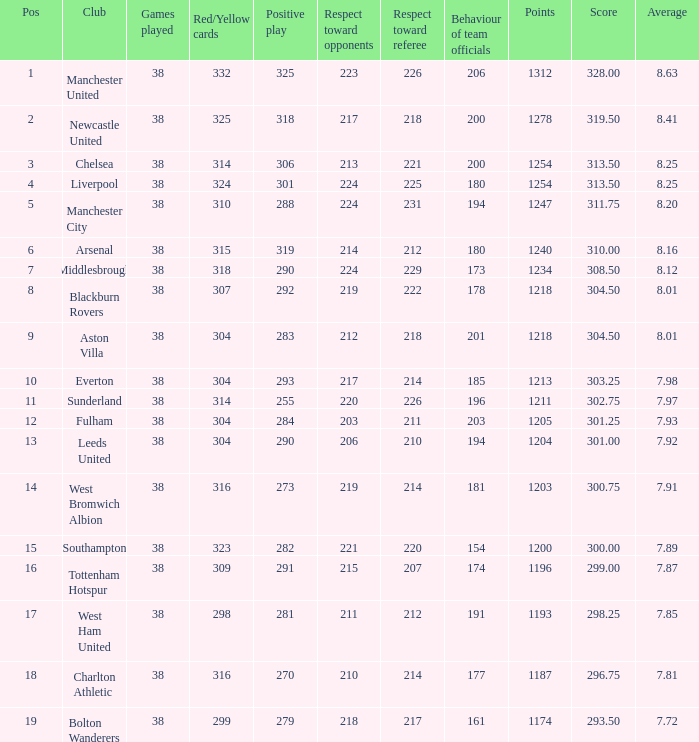Parse the table in full. {'header': ['Pos', 'Club', 'Games played', 'Red/Yellow cards', 'Positive play', 'Respect toward opponents', 'Respect toward referee', 'Behaviour of team officials', 'Points', 'Score', 'Average'], 'rows': [['1', 'Manchester United', '38', '332', '325', '223', '226', '206', '1312', '328.00', '8.63'], ['2', 'Newcastle United', '38', '325', '318', '217', '218', '200', '1278', '319.50', '8.41'], ['3', 'Chelsea', '38', '314', '306', '213', '221', '200', '1254', '313.50', '8.25'], ['4', 'Liverpool', '38', '324', '301', '224', '225', '180', '1254', '313.50', '8.25'], ['5', 'Manchester City', '38', '310', '288', '224', '231', '194', '1247', '311.75', '8.20'], ['6', 'Arsenal', '38', '315', '319', '214', '212', '180', '1240', '310.00', '8.16'], ['7', 'Middlesbrough', '38', '318', '290', '224', '229', '173', '1234', '308.50', '8.12'], ['8', 'Blackburn Rovers', '38', '307', '292', '219', '222', '178', '1218', '304.50', '8.01'], ['9', 'Aston Villa', '38', '304', '283', '212', '218', '201', '1218', '304.50', '8.01'], ['10', 'Everton', '38', '304', '293', '217', '214', '185', '1213', '303.25', '7.98'], ['11', 'Sunderland', '38', '314', '255', '220', '226', '196', '1211', '302.75', '7.97'], ['12', 'Fulham', '38', '304', '284', '203', '211', '203', '1205', '301.25', '7.93'], ['13', 'Leeds United', '38', '304', '290', '206', '210', '194', '1204', '301.00', '7.92'], ['14', 'West Bromwich Albion', '38', '316', '273', '219', '214', '181', '1203', '300.75', '7.91'], ['15', 'Southampton', '38', '323', '282', '221', '220', '154', '1200', '300.00', '7.89'], ['16', 'Tottenham Hotspur', '38', '309', '291', '215', '207', '174', '1196', '299.00', '7.87'], ['17', 'West Ham United', '38', '298', '281', '211', '212', '191', '1193', '298.25', '7.85'], ['18', 'Charlton Athletic', '38', '316', '270', '210', '214', '177', '1187', '296.75', '7.81'], ['19', 'Bolton Wanderers', '38', '299', '279', '218', '217', '161', '1174', '293.50', '7.72']]} Name the most red/yellow cards for positive play being 255 314.0. 